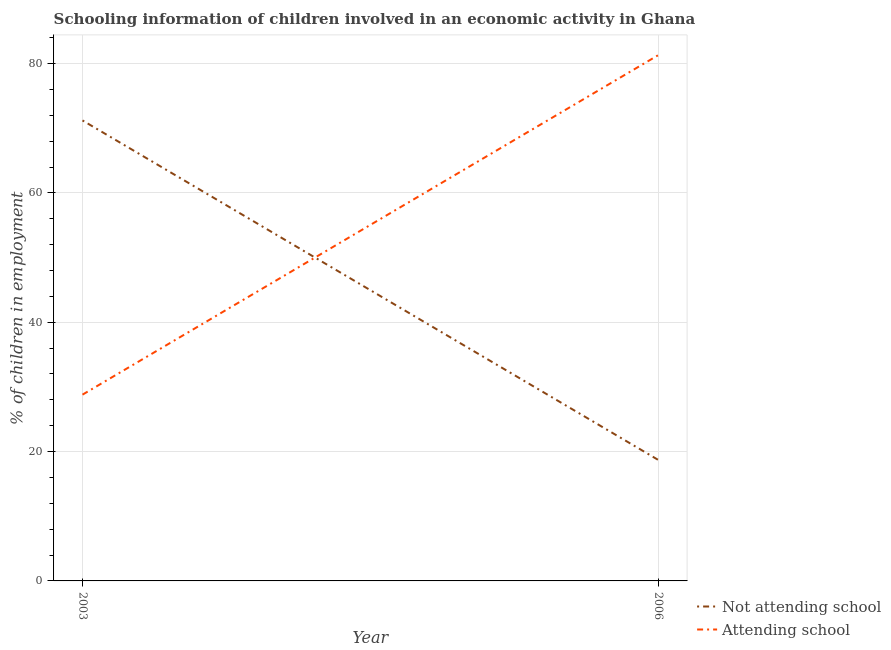Does the line corresponding to percentage of employed children who are attending school intersect with the line corresponding to percentage of employed children who are not attending school?
Keep it short and to the point. Yes. What is the percentage of employed children who are not attending school in 2003?
Provide a succinct answer. 71.2. Across all years, what is the maximum percentage of employed children who are not attending school?
Ensure brevity in your answer.  71.2. Across all years, what is the minimum percentage of employed children who are not attending school?
Provide a short and direct response. 18.7. What is the total percentage of employed children who are not attending school in the graph?
Make the answer very short. 89.9. What is the difference between the percentage of employed children who are attending school in 2003 and that in 2006?
Your response must be concise. -52.5. What is the difference between the percentage of employed children who are attending school in 2006 and the percentage of employed children who are not attending school in 2003?
Provide a succinct answer. 10.1. What is the average percentage of employed children who are attending school per year?
Your answer should be compact. 55.05. In the year 2006, what is the difference between the percentage of employed children who are attending school and percentage of employed children who are not attending school?
Provide a short and direct response. 62.6. In how many years, is the percentage of employed children who are attending school greater than 40 %?
Provide a succinct answer. 1. What is the ratio of the percentage of employed children who are not attending school in 2003 to that in 2006?
Give a very brief answer. 3.81. Is the percentage of employed children who are not attending school in 2003 less than that in 2006?
Provide a succinct answer. No. Does the percentage of employed children who are attending school monotonically increase over the years?
Provide a succinct answer. Yes. Is the percentage of employed children who are attending school strictly greater than the percentage of employed children who are not attending school over the years?
Provide a succinct answer. No. Is the percentage of employed children who are attending school strictly less than the percentage of employed children who are not attending school over the years?
Offer a very short reply. No. How many years are there in the graph?
Offer a terse response. 2. Does the graph contain any zero values?
Your answer should be compact. No. How many legend labels are there?
Make the answer very short. 2. What is the title of the graph?
Offer a very short reply. Schooling information of children involved in an economic activity in Ghana. Does "Arms imports" appear as one of the legend labels in the graph?
Provide a succinct answer. No. What is the label or title of the X-axis?
Offer a very short reply. Year. What is the label or title of the Y-axis?
Give a very brief answer. % of children in employment. What is the % of children in employment of Not attending school in 2003?
Your response must be concise. 71.2. What is the % of children in employment in Attending school in 2003?
Offer a terse response. 28.8. What is the % of children in employment of Not attending school in 2006?
Your answer should be very brief. 18.7. What is the % of children in employment in Attending school in 2006?
Offer a very short reply. 81.3. Across all years, what is the maximum % of children in employment in Not attending school?
Your answer should be very brief. 71.2. Across all years, what is the maximum % of children in employment in Attending school?
Provide a short and direct response. 81.3. Across all years, what is the minimum % of children in employment of Not attending school?
Provide a succinct answer. 18.7. Across all years, what is the minimum % of children in employment in Attending school?
Your response must be concise. 28.8. What is the total % of children in employment of Not attending school in the graph?
Offer a very short reply. 89.9. What is the total % of children in employment in Attending school in the graph?
Your answer should be compact. 110.1. What is the difference between the % of children in employment in Not attending school in 2003 and that in 2006?
Offer a terse response. 52.5. What is the difference between the % of children in employment of Attending school in 2003 and that in 2006?
Give a very brief answer. -52.5. What is the average % of children in employment of Not attending school per year?
Provide a short and direct response. 44.95. What is the average % of children in employment in Attending school per year?
Make the answer very short. 55.05. In the year 2003, what is the difference between the % of children in employment of Not attending school and % of children in employment of Attending school?
Offer a terse response. 42.4. In the year 2006, what is the difference between the % of children in employment in Not attending school and % of children in employment in Attending school?
Your answer should be very brief. -62.6. What is the ratio of the % of children in employment in Not attending school in 2003 to that in 2006?
Offer a very short reply. 3.81. What is the ratio of the % of children in employment of Attending school in 2003 to that in 2006?
Provide a short and direct response. 0.35. What is the difference between the highest and the second highest % of children in employment of Not attending school?
Ensure brevity in your answer.  52.5. What is the difference between the highest and the second highest % of children in employment of Attending school?
Your answer should be very brief. 52.5. What is the difference between the highest and the lowest % of children in employment in Not attending school?
Your answer should be very brief. 52.5. What is the difference between the highest and the lowest % of children in employment of Attending school?
Keep it short and to the point. 52.5. 